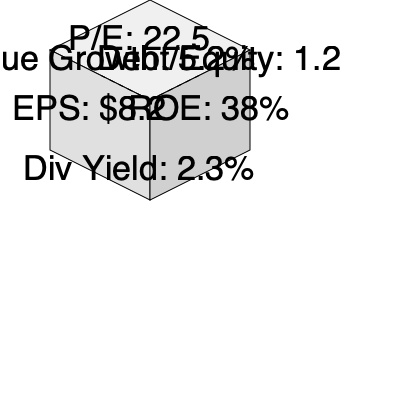A cube representing McDonald's financial metrics is shown above. If the cube is mentally folded, which metric would be on the opposite face of the P/E ratio? To solve this problem, we need to mentally fold the cube and understand its structure:

1. The visible faces of the cube show:
   - Top face: P/E ratio of 22.5
   - Left face: EPS of $8.2
   - Right face: ROE of 38%
   - Front face: Dividend Yield of 2.3%

2. The two hidden faces are indicated by dashed lines and show:
   - Hidden left face: Revenue Growth of 5.2%
   - Hidden right face: Debt/Equity ratio of 1.2

3. In a cube, opposite faces are always parallel to each other and never share an edge.

4. The face opposite to the top face (P/E ratio) would be the bottom face of the cube.

5. The bottom face is not visible in the given perspective, but we can deduce that it must be the Dividend Yield of 2.3%, as this is the only metric that doesn't share an edge with the P/E ratio face.

Therefore, when the cube is mentally folded, the metric opposite to the P/E ratio would be the Dividend Yield.
Answer: Dividend Yield: 2.3% 